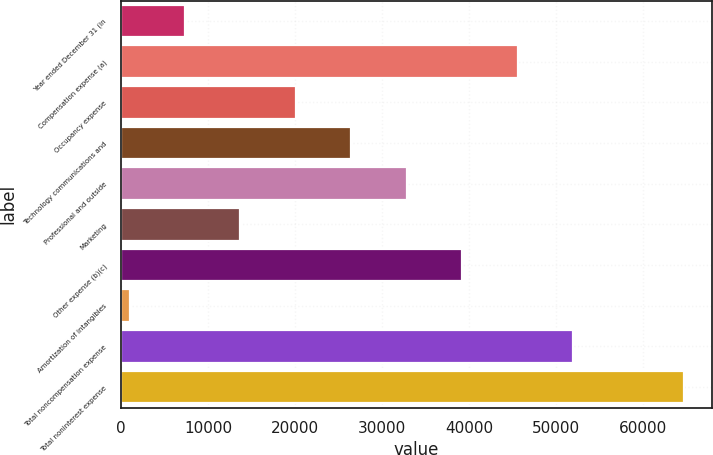<chart> <loc_0><loc_0><loc_500><loc_500><bar_chart><fcel>Year ended December 31 (in<fcel>Compensation expense (a)<fcel>Occupancy expense<fcel>Technology communications and<fcel>Professional and outside<fcel>Marketing<fcel>Other expense (b)(c)<fcel>Amortization of intangibles<fcel>Total noncompensation expense<fcel>Total noninterest expense<nl><fcel>7334.2<fcel>45597.4<fcel>20088.6<fcel>26465.8<fcel>32843<fcel>13711.4<fcel>39220.2<fcel>957<fcel>51974.6<fcel>64729<nl></chart> 